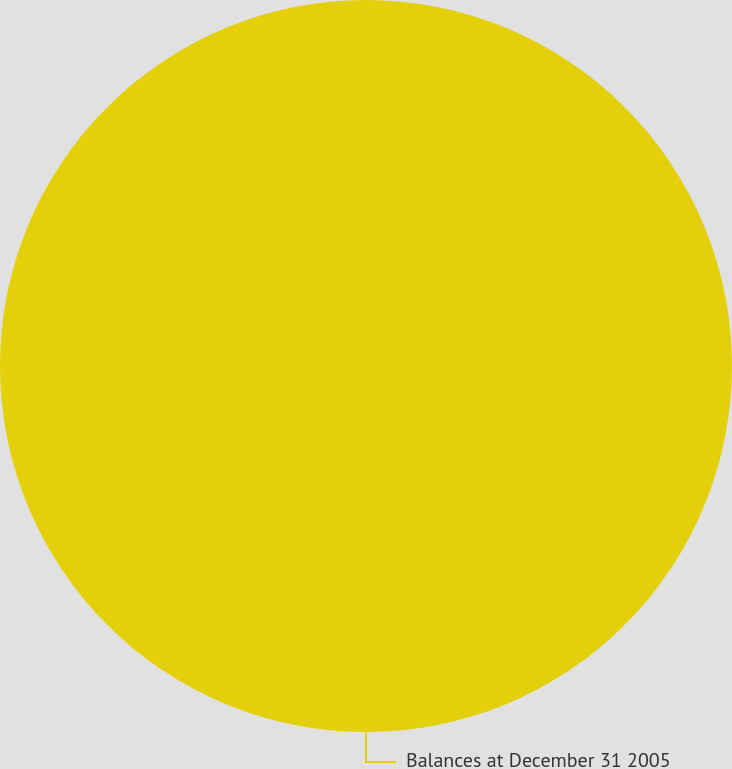Convert chart. <chart><loc_0><loc_0><loc_500><loc_500><pie_chart><fcel>Balances at December 31 2005<nl><fcel>100.0%<nl></chart> 